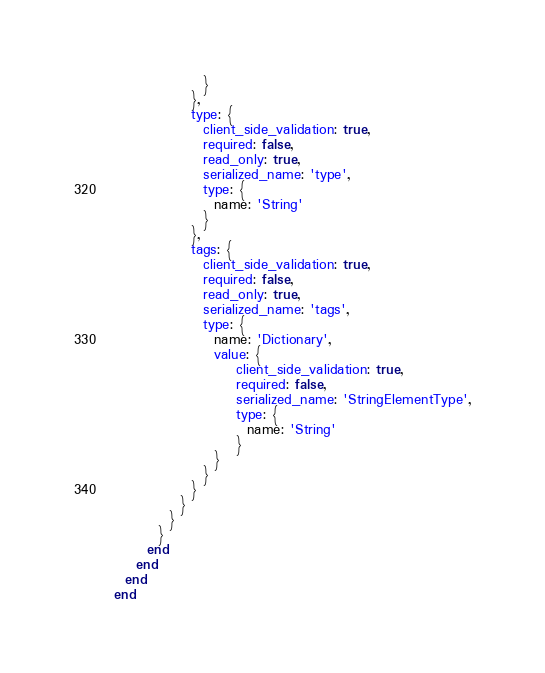<code> <loc_0><loc_0><loc_500><loc_500><_Ruby_>                }
              },
              type: {
                client_side_validation: true,
                required: false,
                read_only: true,
                serialized_name: 'type',
                type: {
                  name: 'String'
                }
              },
              tags: {
                client_side_validation: true,
                required: false,
                read_only: true,
                serialized_name: 'tags',
                type: {
                  name: 'Dictionary',
                  value: {
                      client_side_validation: true,
                      required: false,
                      serialized_name: 'StringElementType',
                      type: {
                        name: 'String'
                      }
                  }
                }
              }
            }
          }
        }
      end
    end
  end
end
</code> 